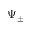Convert formula to latex. <formula><loc_0><loc_0><loc_500><loc_500>\Psi _ { \pm }</formula> 